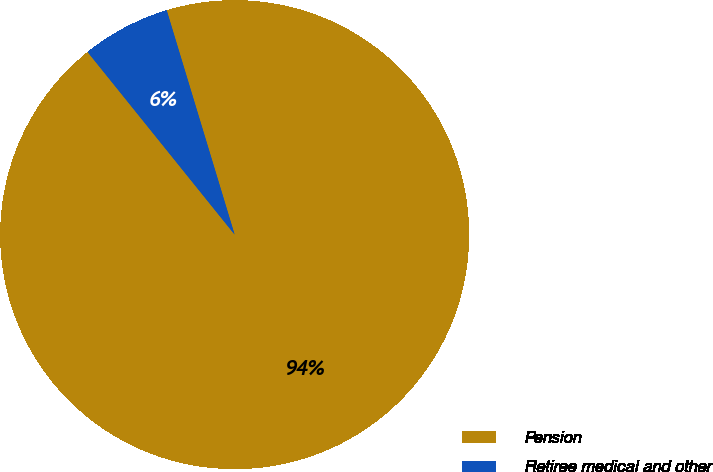Convert chart. <chart><loc_0><loc_0><loc_500><loc_500><pie_chart><fcel>Pension<fcel>Retiree medical and other<nl><fcel>93.89%<fcel>6.11%<nl></chart> 